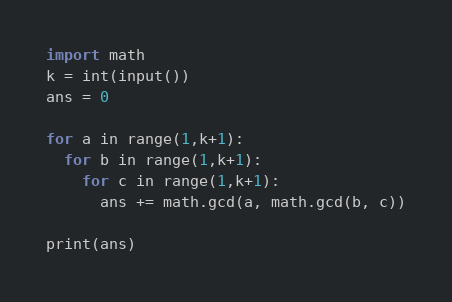<code> <loc_0><loc_0><loc_500><loc_500><_Python_>import math
k = int(input())
ans = 0

for a in range(1,k+1):
  for b in range(1,k+1):
    for c in range(1,k+1):
      ans += math.gcd(a, math.gcd(b, c))

print(ans)</code> 